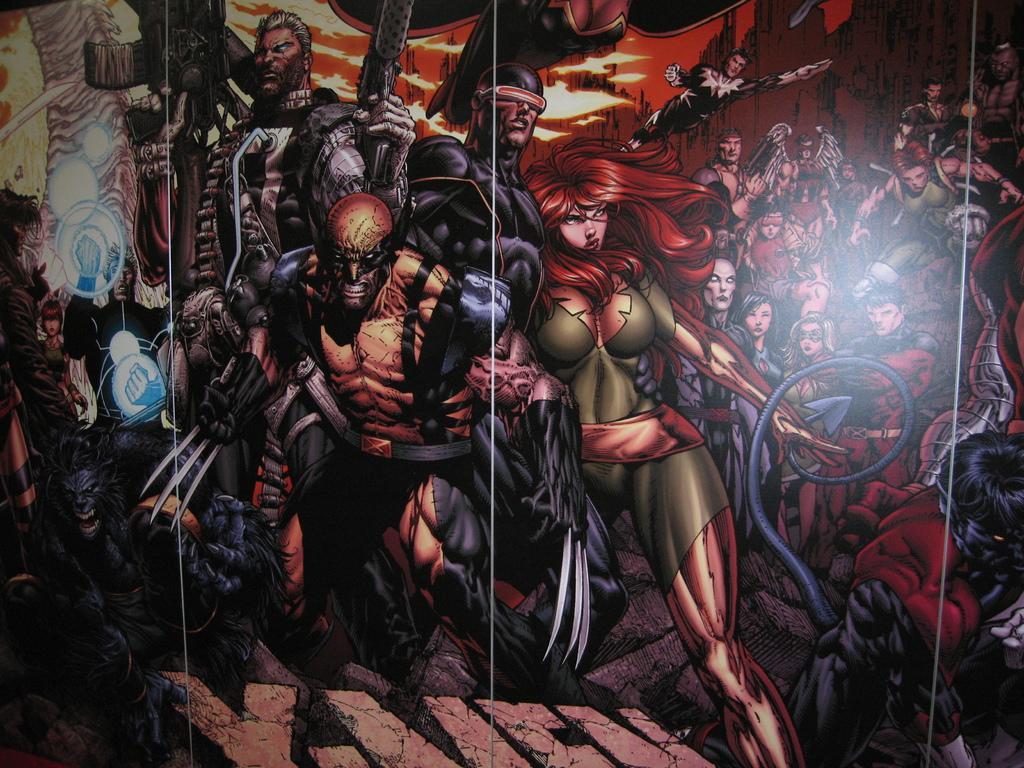In one or two sentences, can you explain what this image depicts? This is a graphical image and I can see few cartoons. 